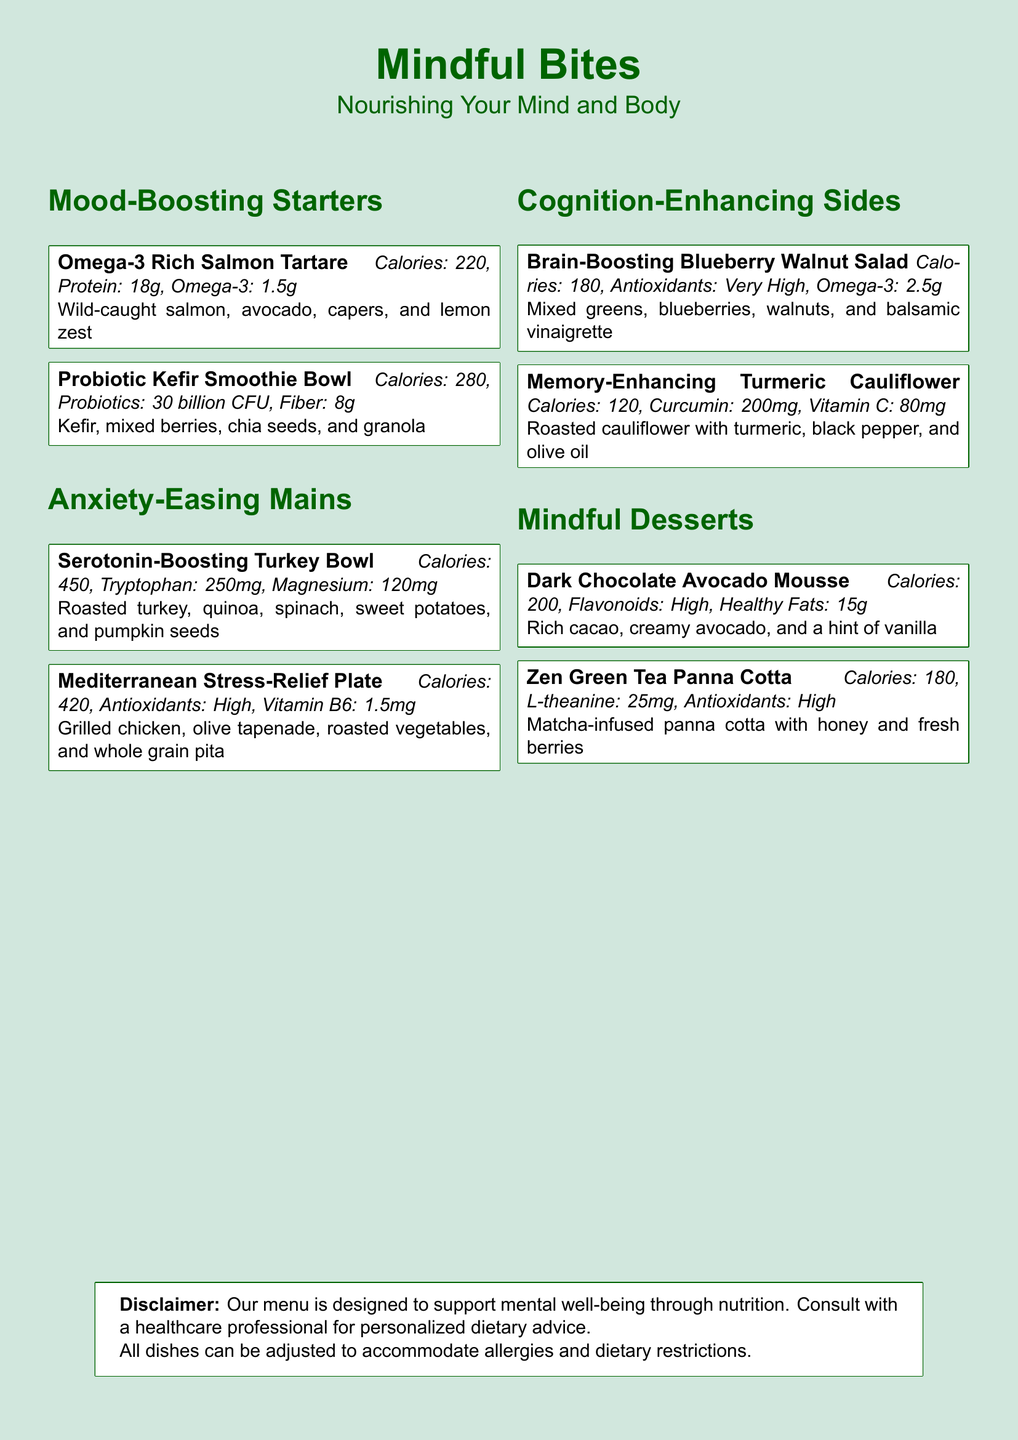What is the name of the eatery? The name of the eatery as stated in the document is "Mindful Bites."
Answer: Mindful Bites How many calories does the Omega-3 Rich Salmon Tartare contain? The document lists that the Omega-3 Rich Salmon Tartare has 220 calories.
Answer: 220 What is a primary ingredient in the Probiotic Kefir Smoothie Bowl? The main ingredients listed for the Probiotic Kefir Smoothie Bowl include kefir and mixed berries.
Answer: Kefir Which menu item contains turkey? The dish that includes turkey is called the "Serotonin-Boosting Turkey Bowl."
Answer: Serotonin-Boosting Turkey Bowl How many grams of protein are in the Dark Chocolate Avocado Mousse? The nutritional information for the Dark Chocolate Avocado Mousse is not explicitly stated; therefore, we cannot determine the protein content directly from the document.
Answer: Not specified Which ingredient in the Memory-Enhancing Turmeric Cauliflower helps with inflammation? The key ingredient that aids in inflammation from the Memory-Enhancing Turmeric Cauliflower is turmeric.
Answer: Turmeric How many billion CFU of probiotics are in the Probiotic Kefir Smoothie Bowl? The amount of probiotics in the Probiotic Kefir Smoothie Bowl is noted as 30 billion CFU.
Answer: 30 billion CFU Identify the dish with the highest calorie count. Among the main dishes, the one with the highest calorie count is the "Serotonin-Boosting Turkey Bowl" at 450 calories.
Answer: Serotonin-Boosting Turkey Bowl What type of fats are abundant in the Dark Chocolate Avocado Mousse? The Dark Chocolate Avocado Mousse contains healthy fats, which are specifically mentioned in the description.
Answer: Healthy fats 